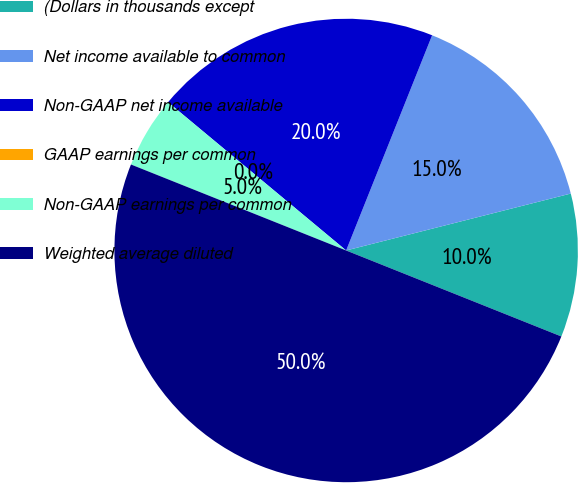<chart> <loc_0><loc_0><loc_500><loc_500><pie_chart><fcel>(Dollars in thousands except<fcel>Net income available to common<fcel>Non-GAAP net income available<fcel>GAAP earnings per common<fcel>Non-GAAP earnings per common<fcel>Weighted average diluted<nl><fcel>10.0%<fcel>15.0%<fcel>20.0%<fcel>0.0%<fcel>5.0%<fcel>50.0%<nl></chart> 